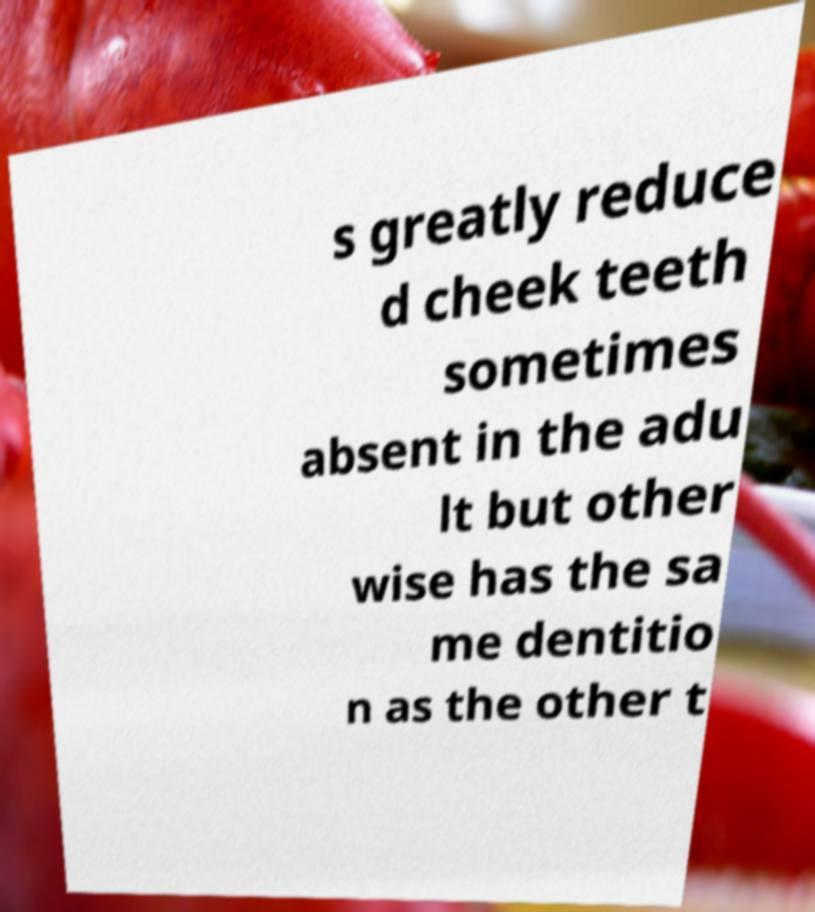Can you read and provide the text displayed in the image?This photo seems to have some interesting text. Can you extract and type it out for me? s greatly reduce d cheek teeth sometimes absent in the adu lt but other wise has the sa me dentitio n as the other t 